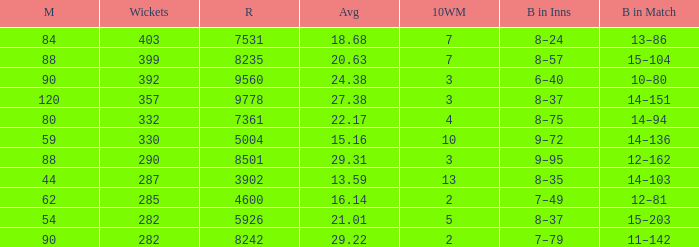Could you parse the entire table? {'header': ['M', 'Wickets', 'R', 'Avg', '10WM', 'B in Inns', 'B in Match'], 'rows': [['84', '403', '7531', '18.68', '7', '8–24', '13–86'], ['88', '399', '8235', '20.63', '7', '8–57', '15–104'], ['90', '392', '9560', '24.38', '3', '6–40', '10–80'], ['120', '357', '9778', '27.38', '3', '8–37', '14–151'], ['80', '332', '7361', '22.17', '4', '8–75', '14–94'], ['59', '330', '5004', '15.16', '10', '9–72', '14–136'], ['88', '290', '8501', '29.31', '3', '9–95', '12–162'], ['44', '287', '3902', '13.59', '13', '8–35', '14–103'], ['62', '285', '4600', '16.14', '2', '7–49', '12–81'], ['54', '282', '5926', '21.01', '5', '8–37', '15–203'], ['90', '282', '8242', '29.22', '2', '7–79', '11–142']]} What is the sum of runs that are associated with 10WM values over 13? None. 